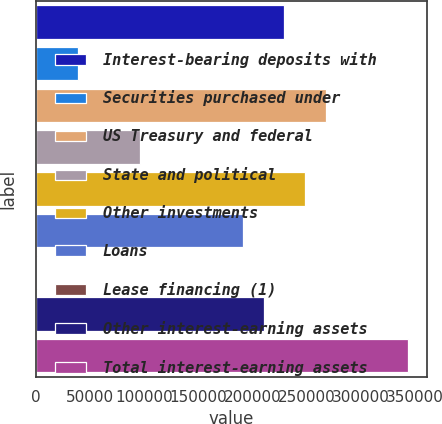Convert chart. <chart><loc_0><loc_0><loc_500><loc_500><bar_chart><fcel>Interest-bearing deposits with<fcel>Securities purchased under<fcel>US Treasury and federal<fcel>State and political<fcel>Other investments<fcel>Loans<fcel>Lease financing (1)<fcel>Other interest-earning assets<fcel>Total interest-earning assets<nl><fcel>229329<fcel>38860.6<fcel>267422<fcel>96001<fcel>248375<fcel>191235<fcel>767<fcel>210282<fcel>343609<nl></chart> 